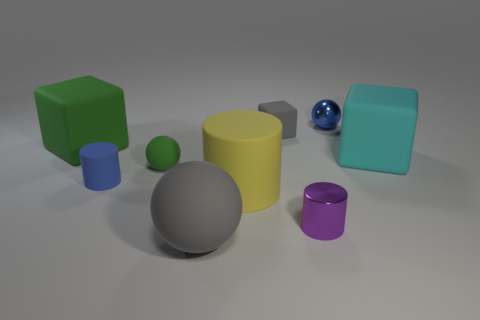Add 1 large yellow cylinders. How many objects exist? 10 Subtract all rubber balls. How many balls are left? 1 Subtract all gray balls. How many balls are left? 2 Subtract all cylinders. How many objects are left? 6 Subtract 2 cylinders. How many cylinders are left? 1 Subtract 0 green cylinders. How many objects are left? 9 Subtract all blue spheres. Subtract all red blocks. How many spheres are left? 2 Subtract all tiny blue things. Subtract all tiny rubber blocks. How many objects are left? 6 Add 2 large yellow matte things. How many large yellow matte things are left? 3 Add 5 cyan things. How many cyan things exist? 6 